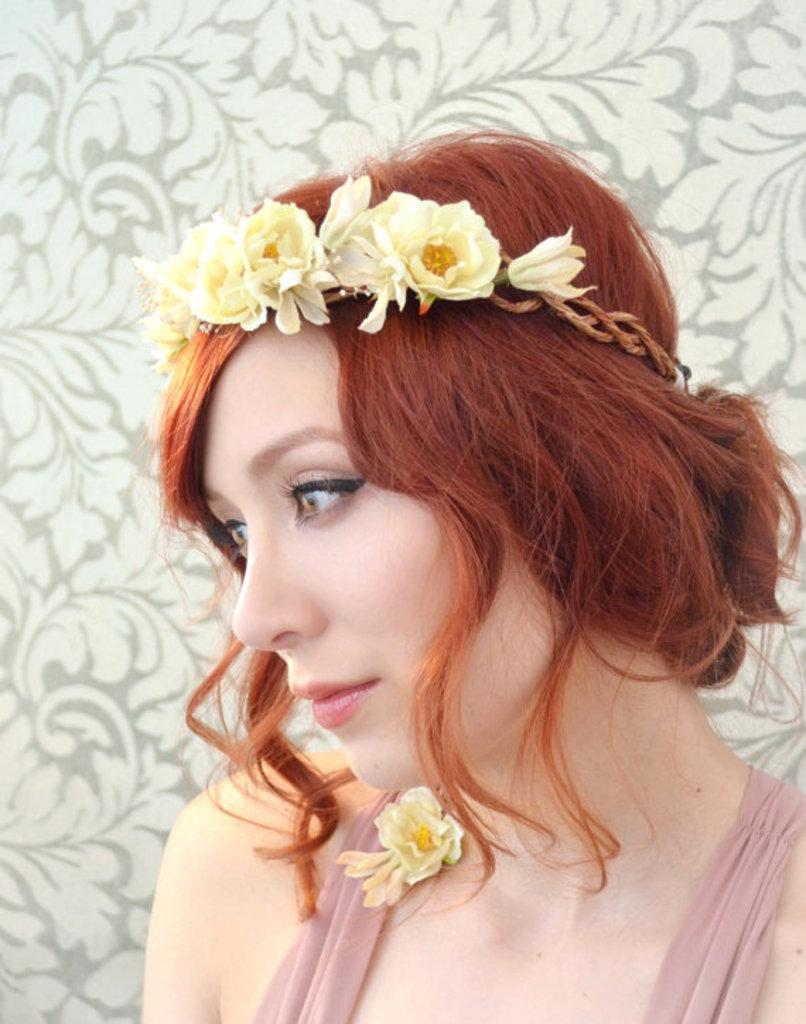Who is the main subject in the image? There is a woman in the image. Can you describe the woman's appearance? The woman has golden hair and is wearing a pink dress. What is the woman wearing on her head? The woman has a tiara on her head. What can be seen in the background of the image? There is a designer wall in the background of the image. How does the woman rest in the image? The image does not show the woman resting; she is standing and posing for the photo. Is there any water visible in the image? No, there is no water present in the image. 